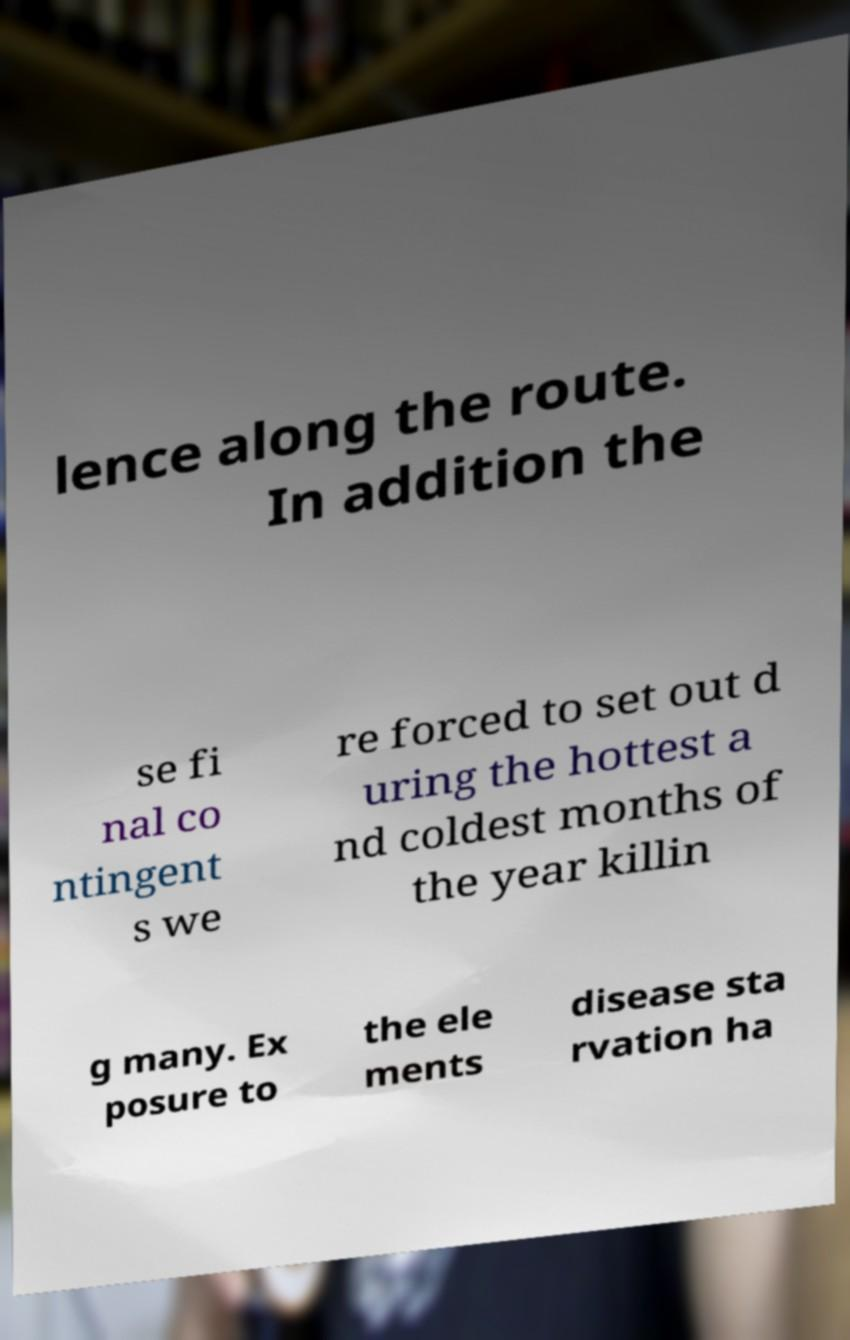Can you accurately transcribe the text from the provided image for me? lence along the route. In addition the se fi nal co ntingent s we re forced to set out d uring the hottest a nd coldest months of the year killin g many. Ex posure to the ele ments disease sta rvation ha 